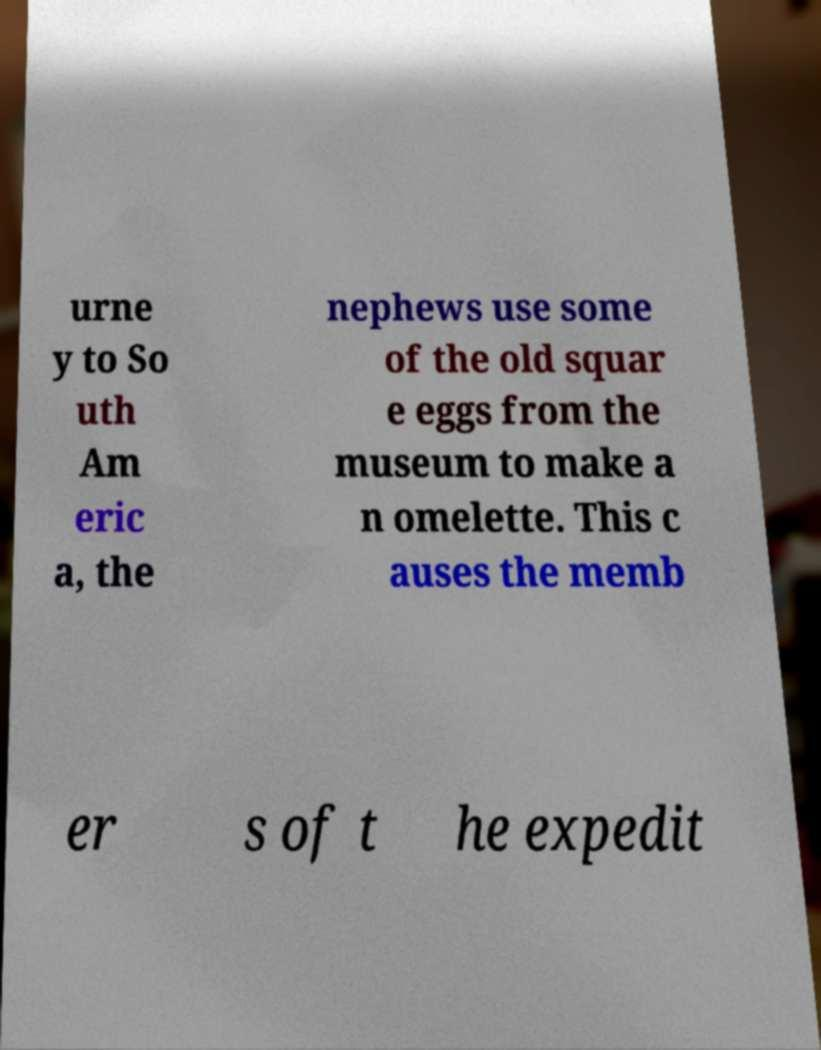Could you assist in decoding the text presented in this image and type it out clearly? urne y to So uth Am eric a, the nephews use some of the old squar e eggs from the museum to make a n omelette. This c auses the memb er s of t he expedit 